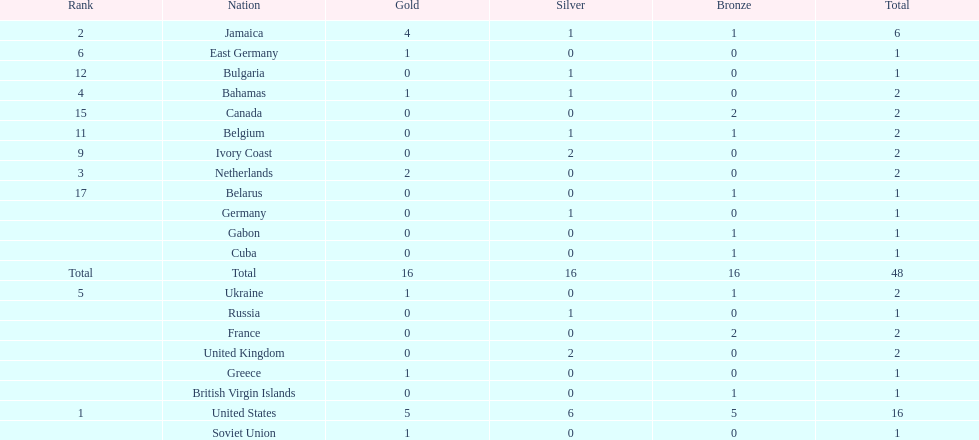Which countries won at least 3 silver medals? United States. Parse the table in full. {'header': ['Rank', 'Nation', 'Gold', 'Silver', 'Bronze', 'Total'], 'rows': [['2', 'Jamaica', '4', '1', '1', '6'], ['6', 'East Germany', '1', '0', '0', '1'], ['12', 'Bulgaria', '0', '1', '0', '1'], ['4', 'Bahamas', '1', '1', '0', '2'], ['15', 'Canada', '0', '0', '2', '2'], ['11', 'Belgium', '0', '1', '1', '2'], ['9', 'Ivory Coast', '0', '2', '0', '2'], ['3', 'Netherlands', '2', '0', '0', '2'], ['17', 'Belarus', '0', '0', '1', '1'], ['', 'Germany', '0', '1', '0', '1'], ['', 'Gabon', '0', '0', '1', '1'], ['', 'Cuba', '0', '0', '1', '1'], ['Total', 'Total', '16', '16', '16', '48'], ['5', 'Ukraine', '1', '0', '1', '2'], ['', 'Russia', '0', '1', '0', '1'], ['', 'France', '0', '0', '2', '2'], ['', 'United Kingdom', '0', '2', '0', '2'], ['', 'Greece', '1', '0', '0', '1'], ['', 'British Virgin Islands', '0', '0', '1', '1'], ['1', 'United States', '5', '6', '5', '16'], ['', 'Soviet Union', '1', '0', '0', '1']]} 